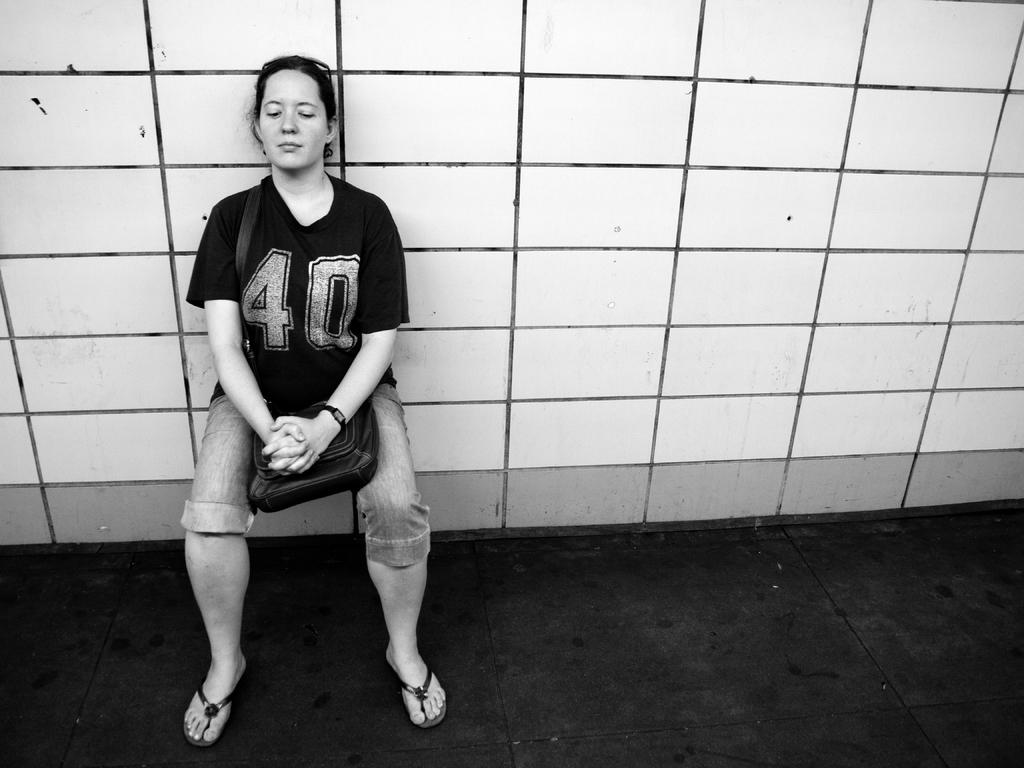What is the main subject of the image? The main subject of the image is a woman. What is the woman doing in the image? The woman is performing a wall chair exercise in the image. Is there any additional information about the woman's attire? Yes, the woman is wearing a bag. What type of gun is the maid holding in the image? There is no maid or gun present in the image. The woman is performing a wall chair exercise, and she is not holding any weapon. 